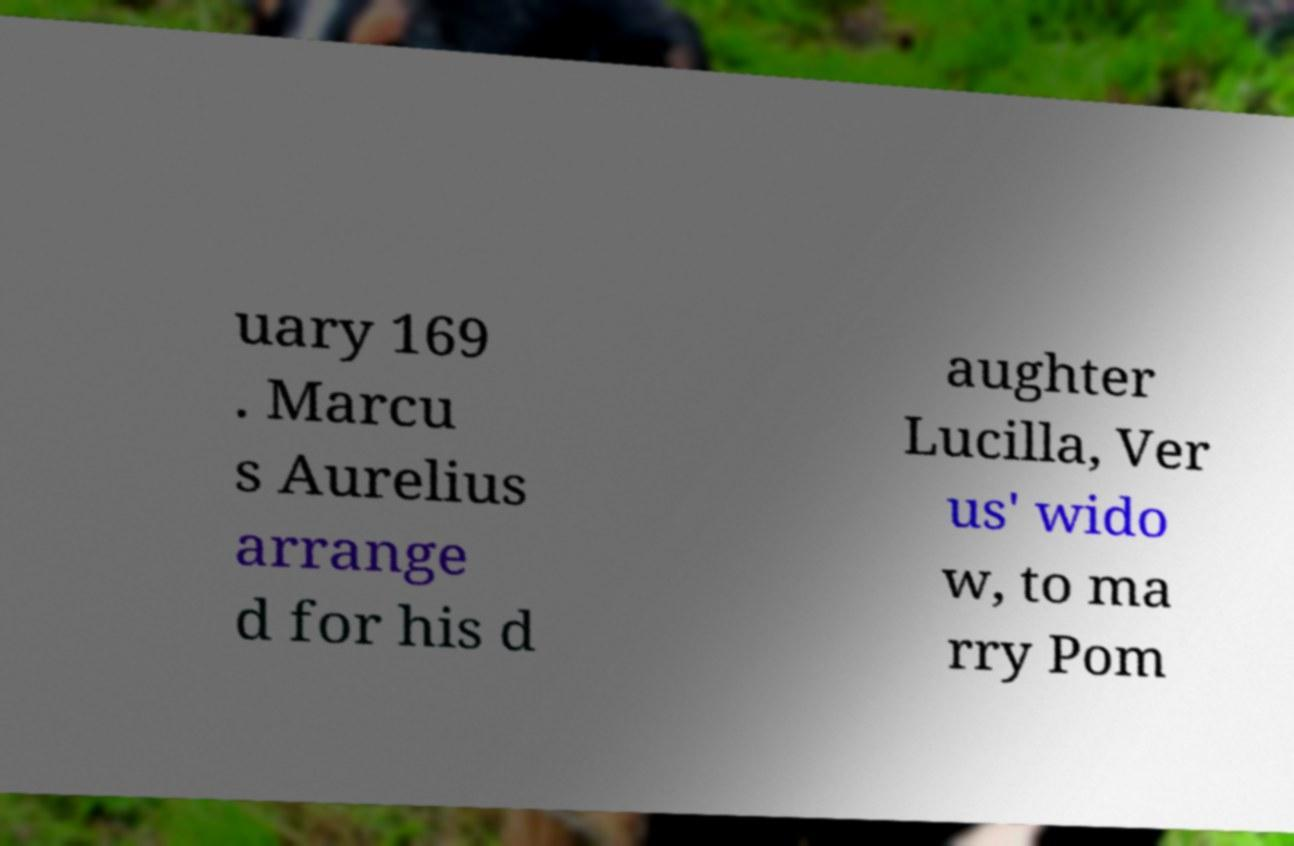Can you read and provide the text displayed in the image?This photo seems to have some interesting text. Can you extract and type it out for me? uary 169 . Marcu s Aurelius arrange d for his d aughter Lucilla, Ver us' wido w, to ma rry Pom 